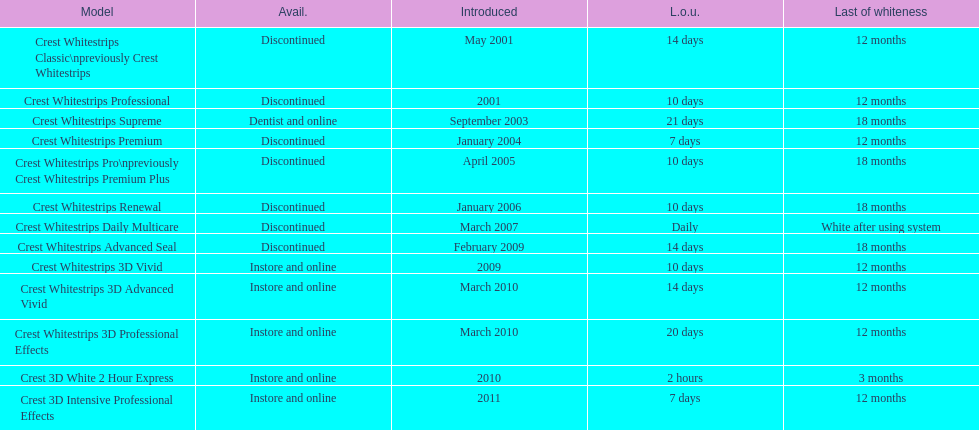Which model has the highest 'length of use' to 'last of whiteness' ratio? Crest Whitestrips Supreme. 